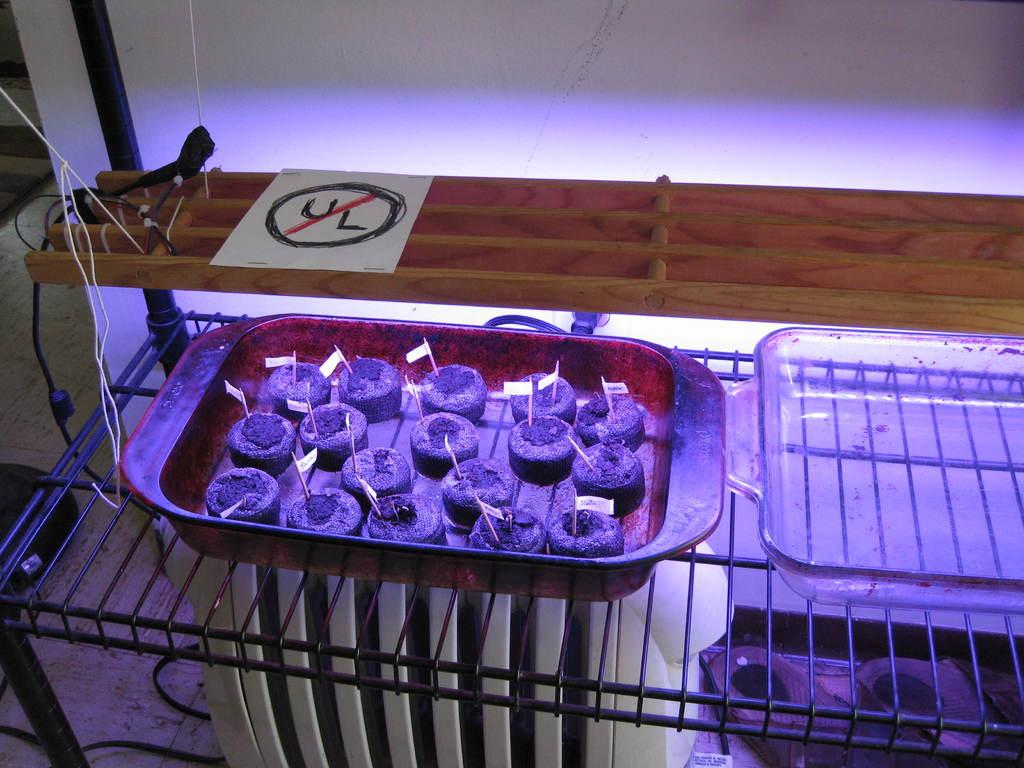<image>
Share a concise interpretation of the image provided. A tray full of cookies sitting on a rack with a sticker that says no U/L. 